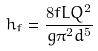Convert formula to latex. <formula><loc_0><loc_0><loc_500><loc_500>h _ { f } = \frac { 8 f L Q ^ { 2 } } { g \pi ^ { 2 } d ^ { 5 } }</formula> 